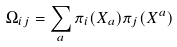Convert formula to latex. <formula><loc_0><loc_0><loc_500><loc_500>\Omega _ { i j } = \sum _ { a } \pi _ { i } ( X _ { a } ) \pi _ { j } ( X ^ { a } )</formula> 